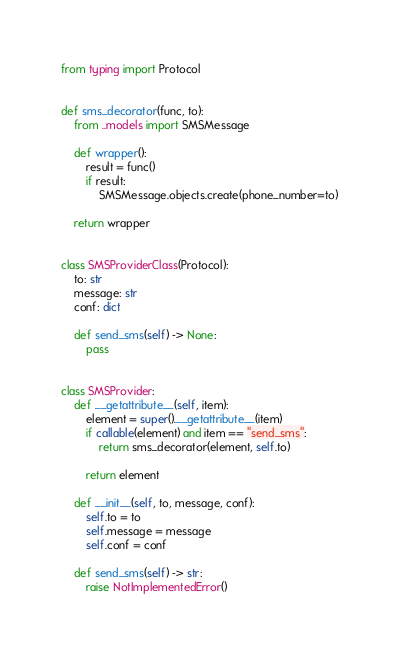Convert code to text. <code><loc_0><loc_0><loc_500><loc_500><_Python_>from typing import Protocol


def sms_decorator(func, to):
    from ..models import SMSMessage

    def wrapper():
        result = func()
        if result:
            SMSMessage.objects.create(phone_number=to)

    return wrapper


class SMSProviderClass(Protocol):
    to: str
    message: str
    conf: dict

    def send_sms(self) -> None:
        pass


class SMSProvider:
    def __getattribute__(self, item):
        element = super().__getattribute__(item)
        if callable(element) and item == "send_sms":
            return sms_decorator(element, self.to)

        return element

    def __init__(self, to, message, conf):
        self.to = to
        self.message = message
        self.conf = conf

    def send_sms(self) -> str:
        raise NotImplementedError()
</code> 